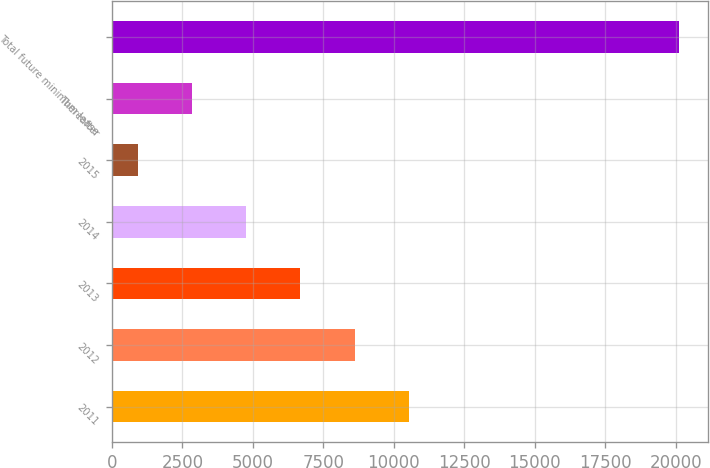Convert chart. <chart><loc_0><loc_0><loc_500><loc_500><bar_chart><fcel>2011<fcel>2012<fcel>2013<fcel>2014<fcel>2015<fcel>Thereafter<fcel>Total future minimum lease<nl><fcel>10530.5<fcel>8610<fcel>6689.5<fcel>4769<fcel>928<fcel>2848.5<fcel>20133<nl></chart> 